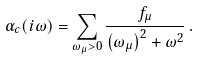<formula> <loc_0><loc_0><loc_500><loc_500>\alpha _ { c } ( i \omega ) = \sum _ { \omega _ { \mu } > 0 } \frac { f _ { \mu } } { \left ( \omega _ { \mu } \right ) ^ { 2 } + \omega ^ { 2 } } \, .</formula> 